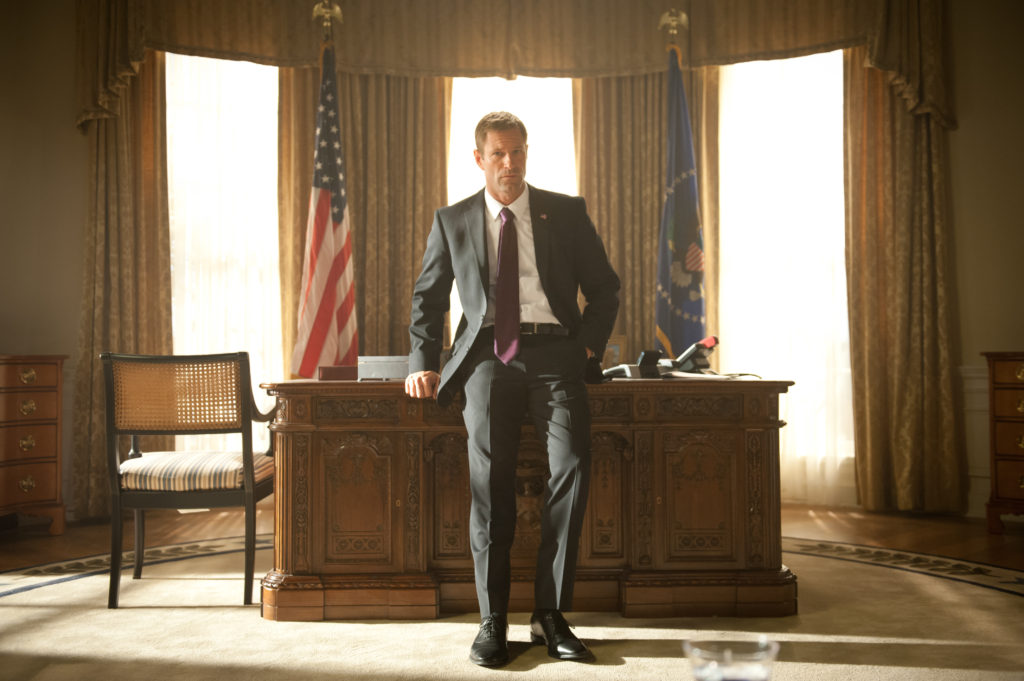Describe the room's décor and its significance. The room's décor is classic and formal, befitting the office of a high-ranking official, most likely the President. The large wooden desk at the center is ornate, with intricate carvings that exhibit craftsmanship and attention to detail. Behind the desk, the American flag and a blue flag featuring a golden eagle symbolize patriotism and presidential authority. The curtains are plush and heavy, framing the windows that allow natural light to softly illuminate the room. The choice of furnishings and decorations exudes elegance, power, and a sense of historical and national pride. Can you imagine a lighthearted moment taking place here? Certainly! Imagine President Asher taking a brief respite from his duties after a long day. He might call in his chief of staff for a quick, lighthearted conversation, reminiscing about their college days or sharing a joke about a recent awkward diplomatic meeting. The tension in the room relaxes momentarily as laughter fills the air, reminding those present that despite the heavy responsibilities, they are still human beings who can share moments of joy and camaraderie. From an artistic perspective, what elements stand out most in this image? Artistically, the interplay of light and shadow stands out, as it highlights the character's contemplative mood and adds depth to the scene. The symmetrical arrangement, with the desk at the center and flags flanking the background, creates a balanced and commanding composition. The textures of the wooden desk and the fabric of the flags contrast with the smooth lines of the character’s suit, adding visual interest. The overall warm color palette enhances the feeling of formality and seriousness, drawing attention to the emotional weight carried by the character. Imagine if President Asher held a secret meeting in this room, what might be discussed? If President Asher were to hold a secret meeting in this room, it might revolve around a covert operation requiring immediate and discreet action. The discussion could involve top military officials and intelligence agents briefing the President on the details of an impending threat from a rogue state or terrorist organization. Plans for a strategic response, including diplomatic channels, cyber tactics, and special operations, would be laid out with precision. The urgency of the conversation would be palpable as they weigh the risks and rewards of their proposed actions, always mindful of the potential global ramifications. 